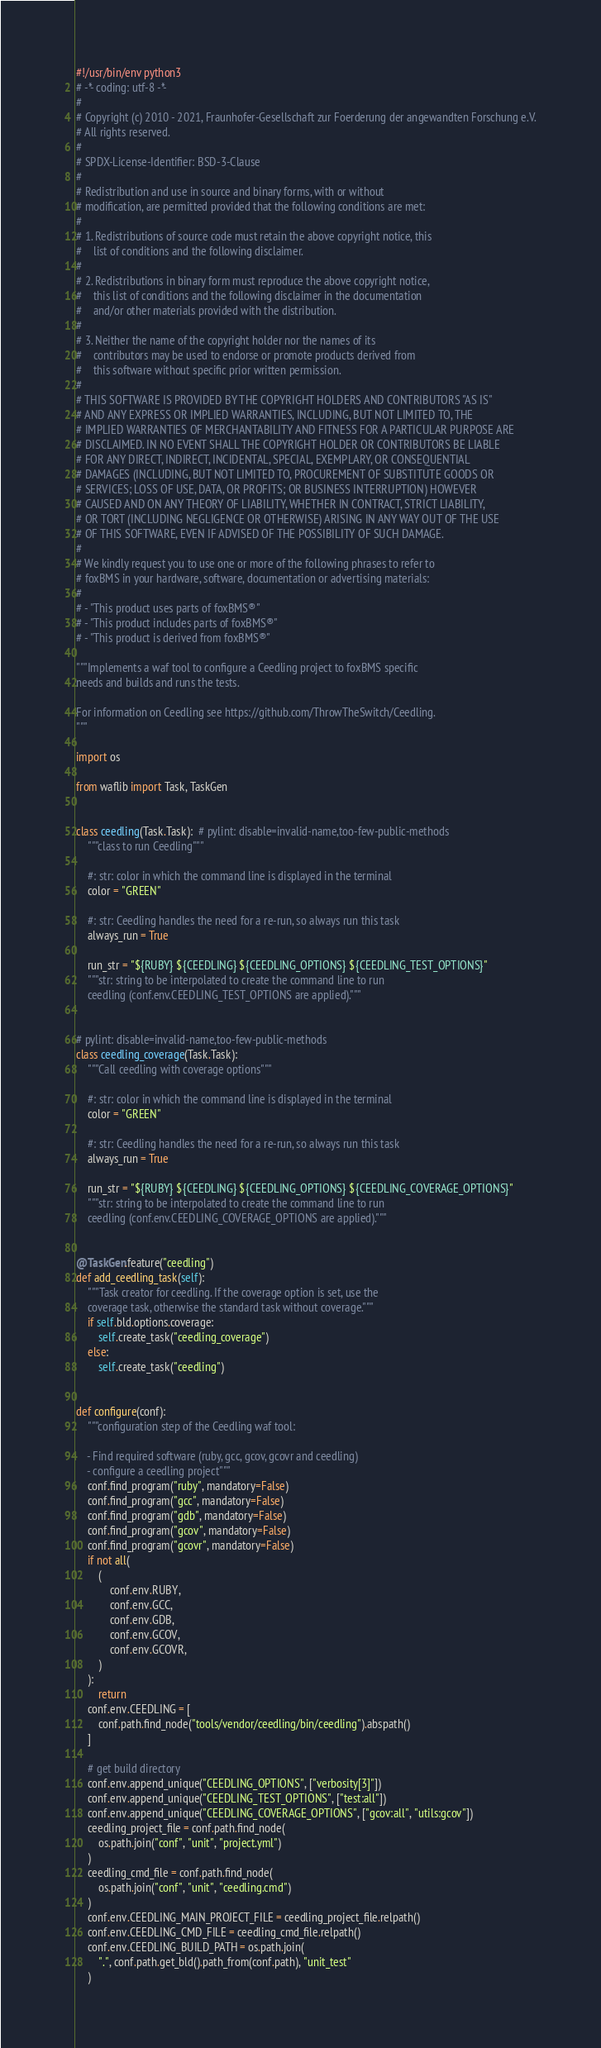<code> <loc_0><loc_0><loc_500><loc_500><_Python_>#!/usr/bin/env python3
# -*- coding: utf-8 -*-
#
# Copyright (c) 2010 - 2021, Fraunhofer-Gesellschaft zur Foerderung der angewandten Forschung e.V.
# All rights reserved.
#
# SPDX-License-Identifier: BSD-3-Clause
#
# Redistribution and use in source and binary forms, with or without
# modification, are permitted provided that the following conditions are met:
#
# 1. Redistributions of source code must retain the above copyright notice, this
#    list of conditions and the following disclaimer.
#
# 2. Redistributions in binary form must reproduce the above copyright notice,
#    this list of conditions and the following disclaimer in the documentation
#    and/or other materials provided with the distribution.
#
# 3. Neither the name of the copyright holder nor the names of its
#    contributors may be used to endorse or promote products derived from
#    this software without specific prior written permission.
#
# THIS SOFTWARE IS PROVIDED BY THE COPYRIGHT HOLDERS AND CONTRIBUTORS "AS IS"
# AND ANY EXPRESS OR IMPLIED WARRANTIES, INCLUDING, BUT NOT LIMITED TO, THE
# IMPLIED WARRANTIES OF MERCHANTABILITY AND FITNESS FOR A PARTICULAR PURPOSE ARE
# DISCLAIMED. IN NO EVENT SHALL THE COPYRIGHT HOLDER OR CONTRIBUTORS BE LIABLE
# FOR ANY DIRECT, INDIRECT, INCIDENTAL, SPECIAL, EXEMPLARY, OR CONSEQUENTIAL
# DAMAGES (INCLUDING, BUT NOT LIMITED TO, PROCUREMENT OF SUBSTITUTE GOODS OR
# SERVICES; LOSS OF USE, DATA, OR PROFITS; OR BUSINESS INTERRUPTION) HOWEVER
# CAUSED AND ON ANY THEORY OF LIABILITY, WHETHER IN CONTRACT, STRICT LIABILITY,
# OR TORT (INCLUDING NEGLIGENCE OR OTHERWISE) ARISING IN ANY WAY OUT OF THE USE
# OF THIS SOFTWARE, EVEN IF ADVISED OF THE POSSIBILITY OF SUCH DAMAGE.
#
# We kindly request you to use one or more of the following phrases to refer to
# foxBMS in your hardware, software, documentation or advertising materials:
#
# - "This product uses parts of foxBMS®"
# - "This product includes parts of foxBMS®"
# - "This product is derived from foxBMS®"

"""Implements a waf tool to configure a Ceedling project to foxBMS specific
needs and builds and runs the tests.

For information on Ceedling see https://github.com/ThrowTheSwitch/Ceedling.
"""

import os

from waflib import Task, TaskGen


class ceedling(Task.Task):  # pylint: disable=invalid-name,too-few-public-methods
    """class to run Ceedling"""

    #: str: color in which the command line is displayed in the terminal
    color = "GREEN"

    #: str: Ceedling handles the need for a re-run, so always run this task
    always_run = True

    run_str = "${RUBY} ${CEEDLING} ${CEEDLING_OPTIONS} ${CEEDLING_TEST_OPTIONS}"
    """str: string to be interpolated to create the command line to run
    ceedling (conf.env.CEEDLING_TEST_OPTIONS are applied)."""


# pylint: disable=invalid-name,too-few-public-methods
class ceedling_coverage(Task.Task):
    """Call ceedling with coverage options"""

    #: str: color in which the command line is displayed in the terminal
    color = "GREEN"

    #: str: Ceedling handles the need for a re-run, so always run this task
    always_run = True

    run_str = "${RUBY} ${CEEDLING} ${CEEDLING_OPTIONS} ${CEEDLING_COVERAGE_OPTIONS}"
    """str: string to be interpolated to create the command line to run
    ceedling (conf.env.CEEDLING_COVERAGE_OPTIONS are applied)."""


@TaskGen.feature("ceedling")
def add_ceedling_task(self):
    """Task creator for ceedling. If the coverage option is set, use the
    coverage task, otherwise the standard task without coverage."""
    if self.bld.options.coverage:
        self.create_task("ceedling_coverage")
    else:
        self.create_task("ceedling")


def configure(conf):
    """configuration step of the Ceedling waf tool:

    - Find required software (ruby, gcc, gcov, gcovr and ceedling)
    - configure a ceedling project"""
    conf.find_program("ruby", mandatory=False)
    conf.find_program("gcc", mandatory=False)
    conf.find_program("gdb", mandatory=False)
    conf.find_program("gcov", mandatory=False)
    conf.find_program("gcovr", mandatory=False)
    if not all(
        (
            conf.env.RUBY,
            conf.env.GCC,
            conf.env.GDB,
            conf.env.GCOV,
            conf.env.GCOVR,
        )
    ):
        return
    conf.env.CEEDLING = [
        conf.path.find_node("tools/vendor/ceedling/bin/ceedling").abspath()
    ]

    # get build directory
    conf.env.append_unique("CEEDLING_OPTIONS", ["verbosity[3]"])
    conf.env.append_unique("CEEDLING_TEST_OPTIONS", ["test:all"])
    conf.env.append_unique("CEEDLING_COVERAGE_OPTIONS", ["gcov:all", "utils:gcov"])
    ceedling_project_file = conf.path.find_node(
        os.path.join("conf", "unit", "project.yml")
    )
    ceedling_cmd_file = conf.path.find_node(
        os.path.join("conf", "unit", "ceedling.cmd")
    )
    conf.env.CEEDLING_MAIN_PROJECT_FILE = ceedling_project_file.relpath()
    conf.env.CEEDLING_CMD_FILE = ceedling_cmd_file.relpath()
    conf.env.CEEDLING_BUILD_PATH = os.path.join(
        ".", conf.path.get_bld().path_from(conf.path), "unit_test"
    )
</code> 